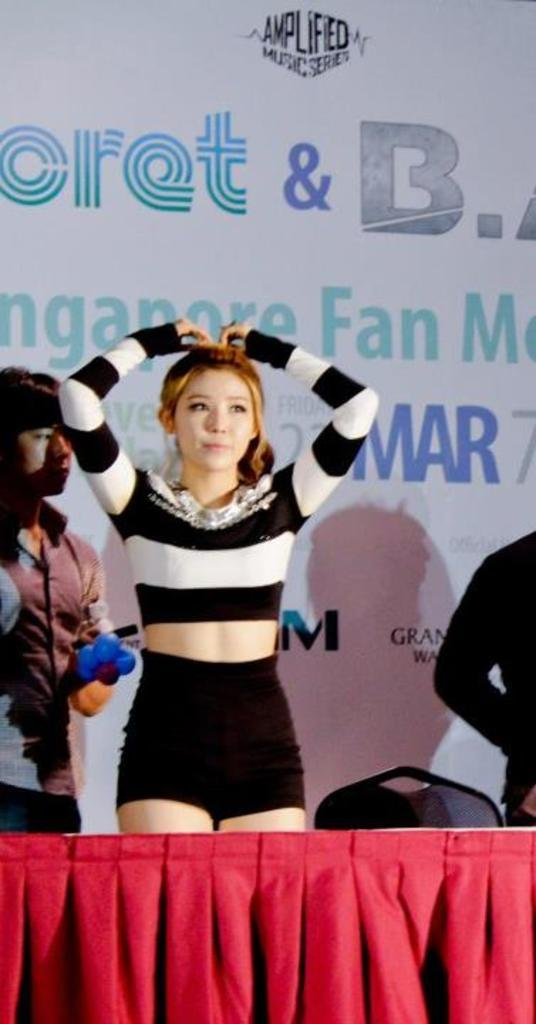<image>
Provide a brief description of the given image. a girl in front of a sign with the word fan on it 